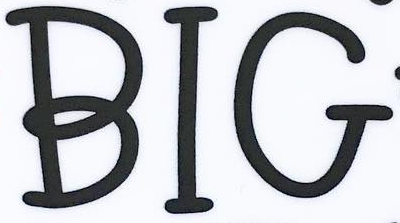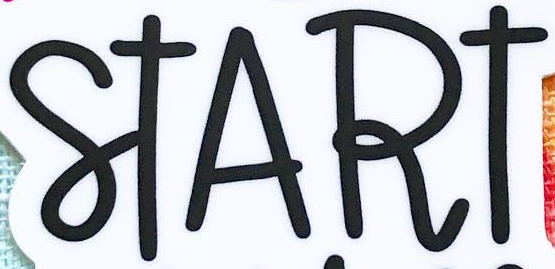What words are shown in these images in order, separated by a semicolon? BIG; START 